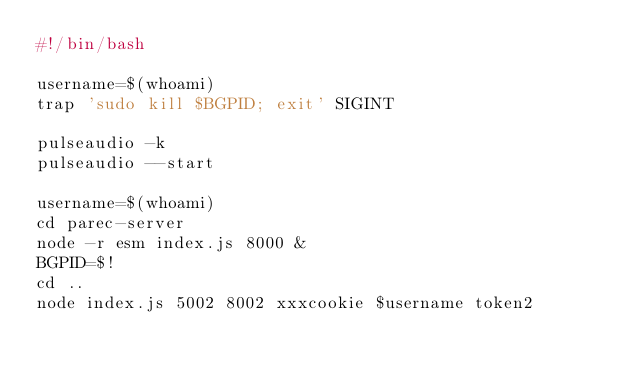<code> <loc_0><loc_0><loc_500><loc_500><_Bash_>#!/bin/bash

username=$(whoami)
trap 'sudo kill $BGPID; exit' SIGINT 

pulseaudio -k
pulseaudio --start

username=$(whoami)
cd parec-server
node -r esm index.js 8000 &
BGPID=$!
cd ..
node index.js 5002 8002 xxxcookie $username token2
</code> 